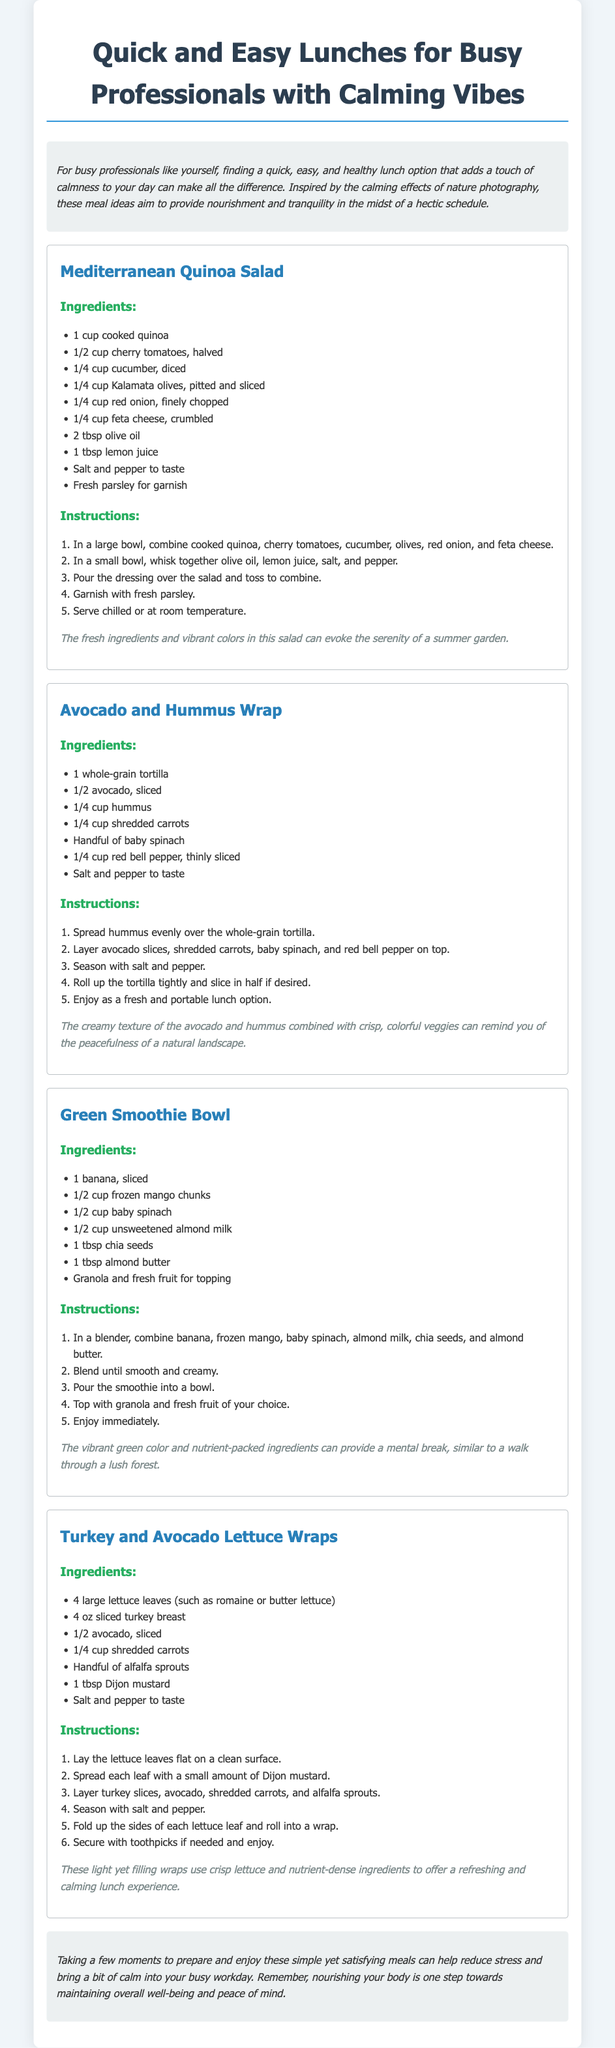What is the title of the document? The title of the document, as indicated in the HTML code, is stated in the title tag.
Answer: Quick and Easy Lunches for Busy Professionals with Calming Vibes How many meals are featured in the document? The document lists four distinct meals in separate sections.
Answer: Four What is one key ingredient in the Mediterranean Quinoa Salad? The salad section lists several ingredients, including cherry tomatoes, cucumber, and feta cheese, among others.
Answer: Feta cheese What type of wrap is mentioned in the document? The document includes a recipe for a specific type of wrap that combines avocado and hummus.
Answer: Avocado and Hummus Wrap What type of lettuce is used for the Turkey and Avocado Lettuce Wraps? The ingredients for the wraps specify the use of large lettuce leaves, with the type named explicitly.
Answer: Romaine or butter lettuce Which meal features a smoothie? The document describes a specific meal that is a beverage served in a bowl format.
Answer: Green Smoothie Bowl What is the purpose of the document? The introduction explains the aim of the meal ideas presented for busy professionals.
Answer: To provide nourishment and tranquility How is the closing note designed to impact the reader? The closing note encourages the reader to reflect on the benefits of meal preparation for stress reduction.
Answer: Reduce stress and bring calm 